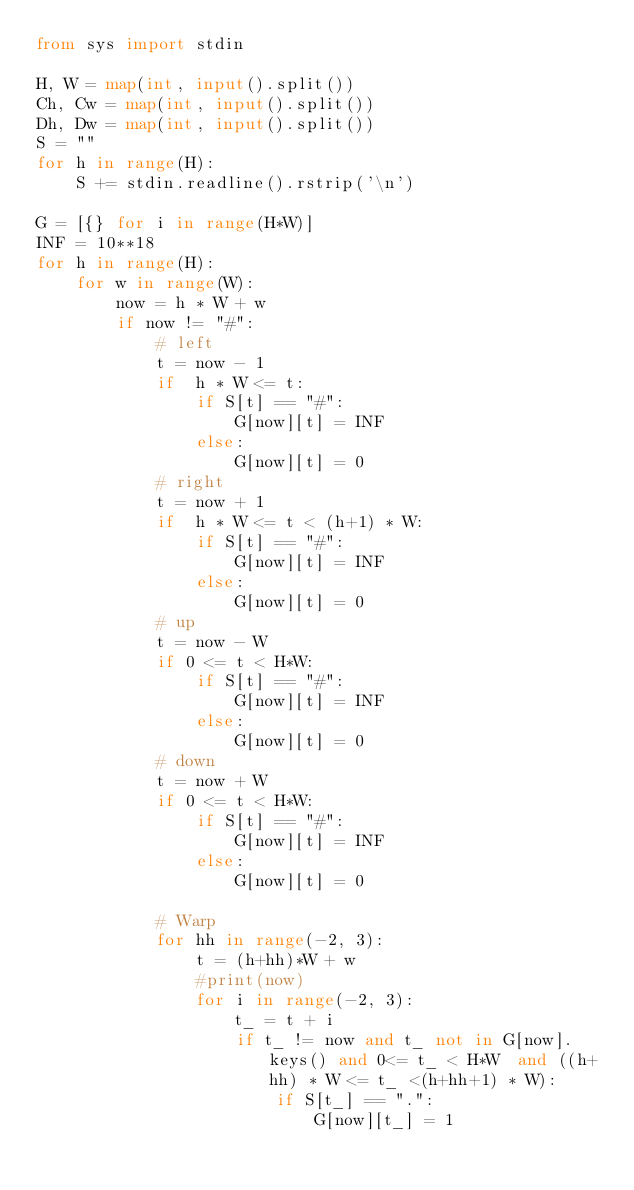Convert code to text. <code><loc_0><loc_0><loc_500><loc_500><_Python_>from sys import stdin

H, W = map(int, input().split())
Ch, Cw = map(int, input().split())
Dh, Dw = map(int, input().split())
S = ""
for h in range(H):
    S += stdin.readline().rstrip('\n')
    
G = [{} for i in range(H*W)]
INF = 10**18
for h in range(H):
    for w in range(W):
        now = h * W + w
        if now != "#":
            # left
            t = now - 1
            if  h * W <= t:
                if S[t] == "#":
                    G[now][t] = INF
                else:
                    G[now][t] = 0
            # right
            t = now + 1
            if  h * W <= t < (h+1) * W:
                if S[t] == "#":
                    G[now][t] = INF
                else:
                    G[now][t] = 0
            # up
            t = now - W
            if 0 <= t < H*W:
                if S[t] == "#":
                    G[now][t] = INF
                else:
                    G[now][t] = 0
            # down
            t = now + W
            if 0 <= t < H*W:
                if S[t] == "#":
                    G[now][t] = INF
                else:
                    G[now][t] = 0
        
            # Warp
            for hh in range(-2, 3):
                t = (h+hh)*W + w
                #print(now)
                for i in range(-2, 3):
                    t_ = t + i
                    if t_ != now and t_ not in G[now].keys() and 0<= t_ < H*W  and ((h+hh) * W <= t_ <(h+hh+1) * W):
                        if S[t_] == ".":
                            G[now][t_] = 1</code> 